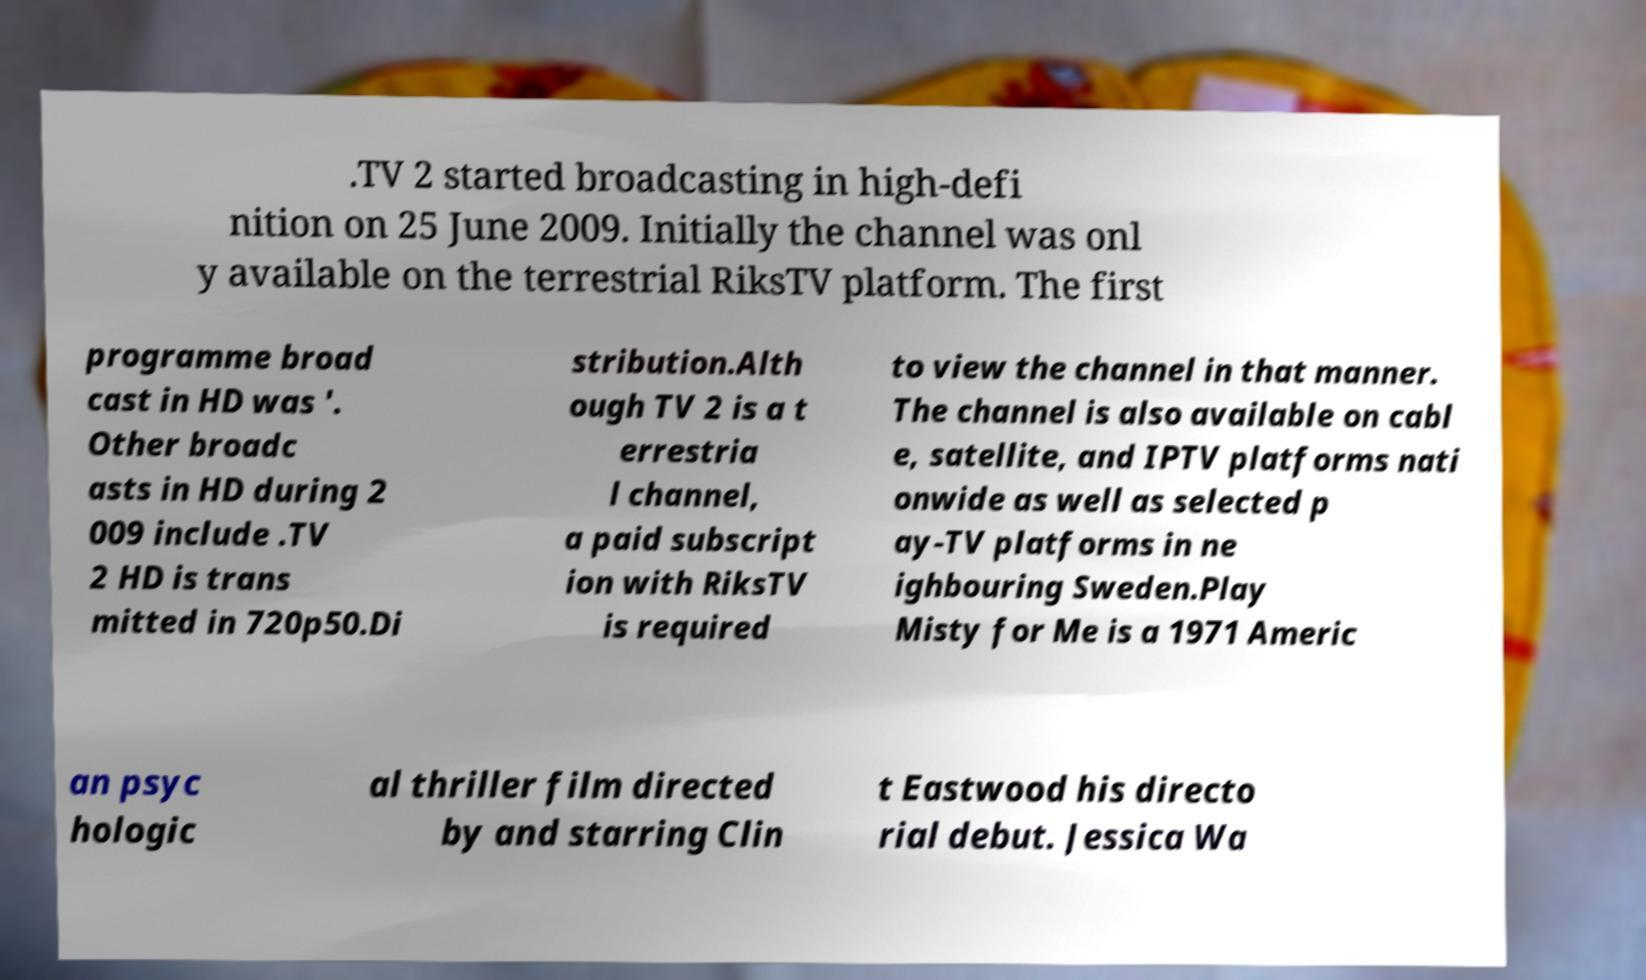Can you read and provide the text displayed in the image?This photo seems to have some interesting text. Can you extract and type it out for me? .TV 2 started broadcasting in high-defi nition on 25 June 2009. Initially the channel was onl y available on the terrestrial RiksTV platform. The first programme broad cast in HD was '. Other broadc asts in HD during 2 009 include .TV 2 HD is trans mitted in 720p50.Di stribution.Alth ough TV 2 is a t errestria l channel, a paid subscript ion with RiksTV is required to view the channel in that manner. The channel is also available on cabl e, satellite, and IPTV platforms nati onwide as well as selected p ay-TV platforms in ne ighbouring Sweden.Play Misty for Me is a 1971 Americ an psyc hologic al thriller film directed by and starring Clin t Eastwood his directo rial debut. Jessica Wa 